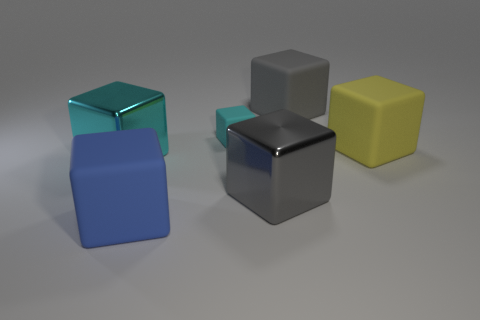Subtract all large gray cubes. How many cubes are left? 4 Subtract all cyan cylinders. How many gray blocks are left? 2 Subtract all cyan cubes. How many cubes are left? 4 Add 3 gray metal things. How many objects exist? 9 Subtract all big gray shiny blocks. Subtract all yellow matte cubes. How many objects are left? 4 Add 5 tiny cyan cubes. How many tiny cyan cubes are left? 6 Add 2 cyan things. How many cyan things exist? 4 Subtract 0 blue spheres. How many objects are left? 6 Subtract all purple blocks. Subtract all purple cylinders. How many blocks are left? 6 